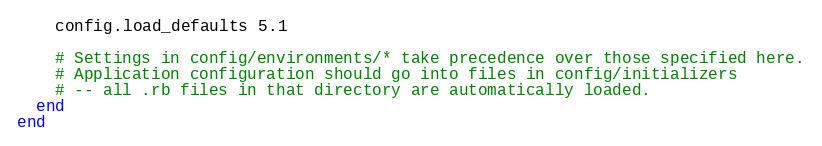<code> <loc_0><loc_0><loc_500><loc_500><_Ruby_>    config.load_defaults 5.1

    # Settings in config/environments/* take precedence over those specified here.
    # Application configuration should go into files in config/initializers
    # -- all .rb files in that directory are automatically loaded.
  end
end

</code> 